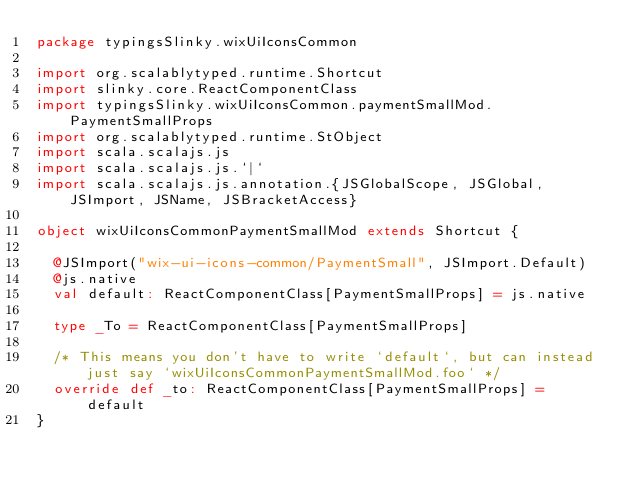<code> <loc_0><loc_0><loc_500><loc_500><_Scala_>package typingsSlinky.wixUiIconsCommon

import org.scalablytyped.runtime.Shortcut
import slinky.core.ReactComponentClass
import typingsSlinky.wixUiIconsCommon.paymentSmallMod.PaymentSmallProps
import org.scalablytyped.runtime.StObject
import scala.scalajs.js
import scala.scalajs.js.`|`
import scala.scalajs.js.annotation.{JSGlobalScope, JSGlobal, JSImport, JSName, JSBracketAccess}

object wixUiIconsCommonPaymentSmallMod extends Shortcut {
  
  @JSImport("wix-ui-icons-common/PaymentSmall", JSImport.Default)
  @js.native
  val default: ReactComponentClass[PaymentSmallProps] = js.native
  
  type _To = ReactComponentClass[PaymentSmallProps]
  
  /* This means you don't have to write `default`, but can instead just say `wixUiIconsCommonPaymentSmallMod.foo` */
  override def _to: ReactComponentClass[PaymentSmallProps] = default
}
</code> 